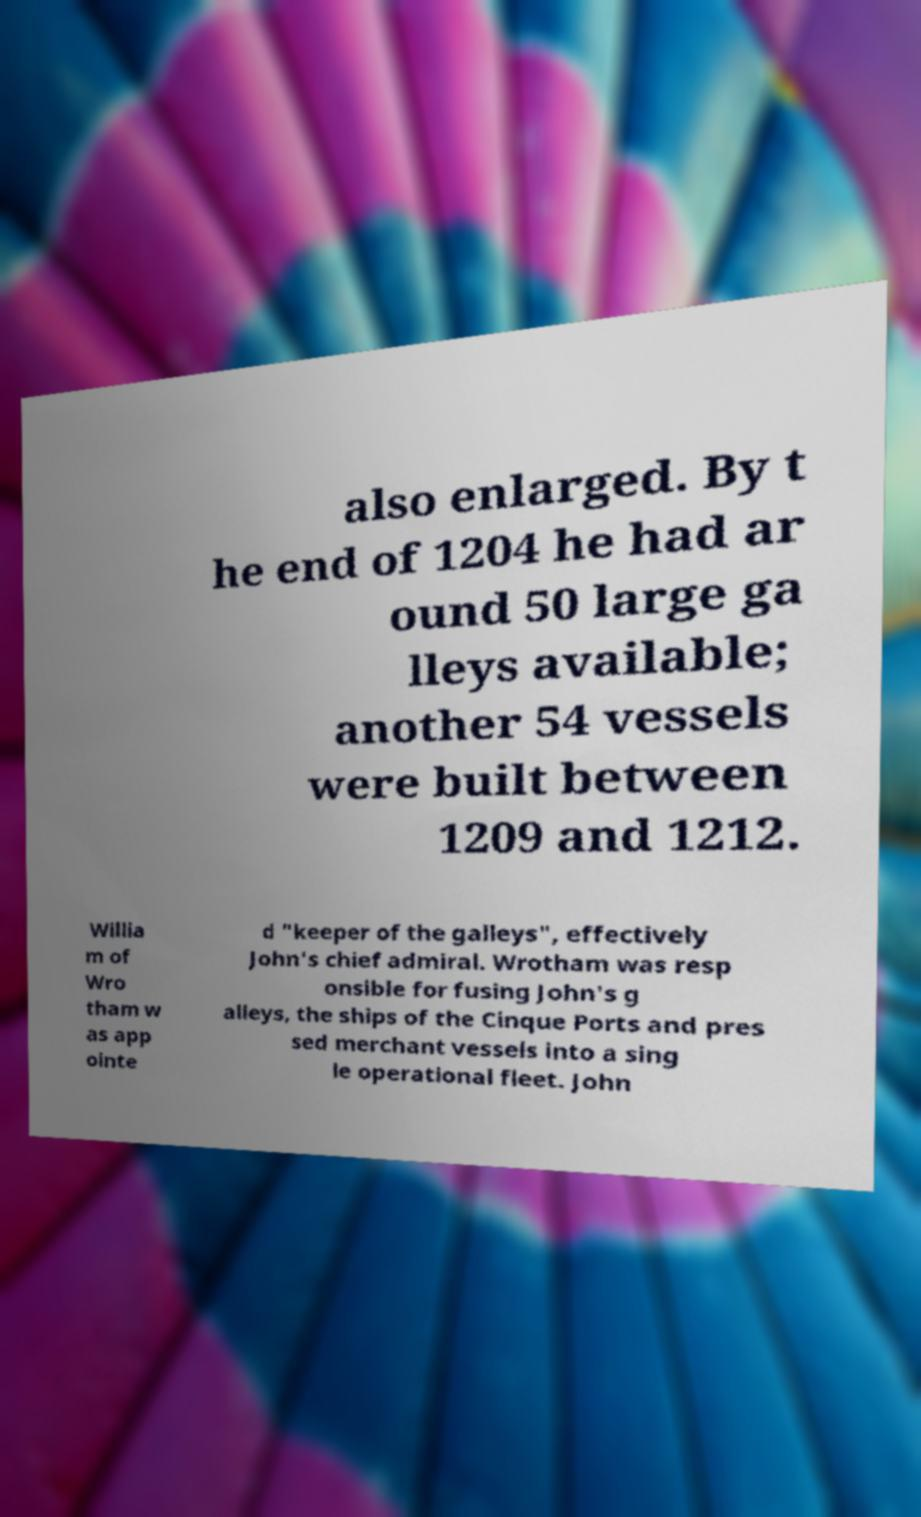There's text embedded in this image that I need extracted. Can you transcribe it verbatim? also enlarged. By t he end of 1204 he had ar ound 50 large ga lleys available; another 54 vessels were built between 1209 and 1212. Willia m of Wro tham w as app ointe d "keeper of the galleys", effectively John's chief admiral. Wrotham was resp onsible for fusing John's g alleys, the ships of the Cinque Ports and pres sed merchant vessels into a sing le operational fleet. John 